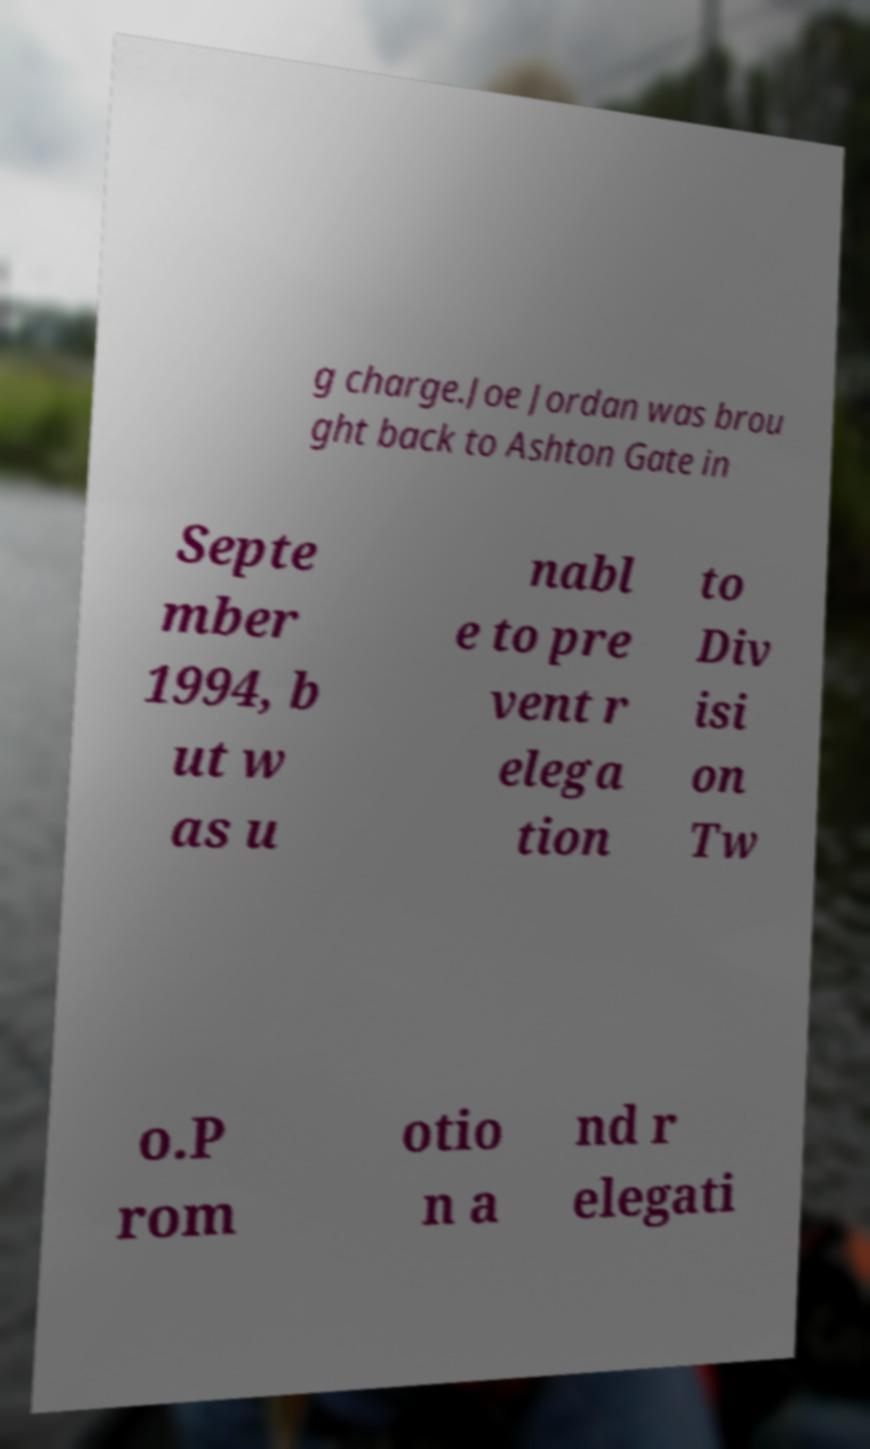Please identify and transcribe the text found in this image. g charge.Joe Jordan was brou ght back to Ashton Gate in Septe mber 1994, b ut w as u nabl e to pre vent r elega tion to Div isi on Tw o.P rom otio n a nd r elegati 